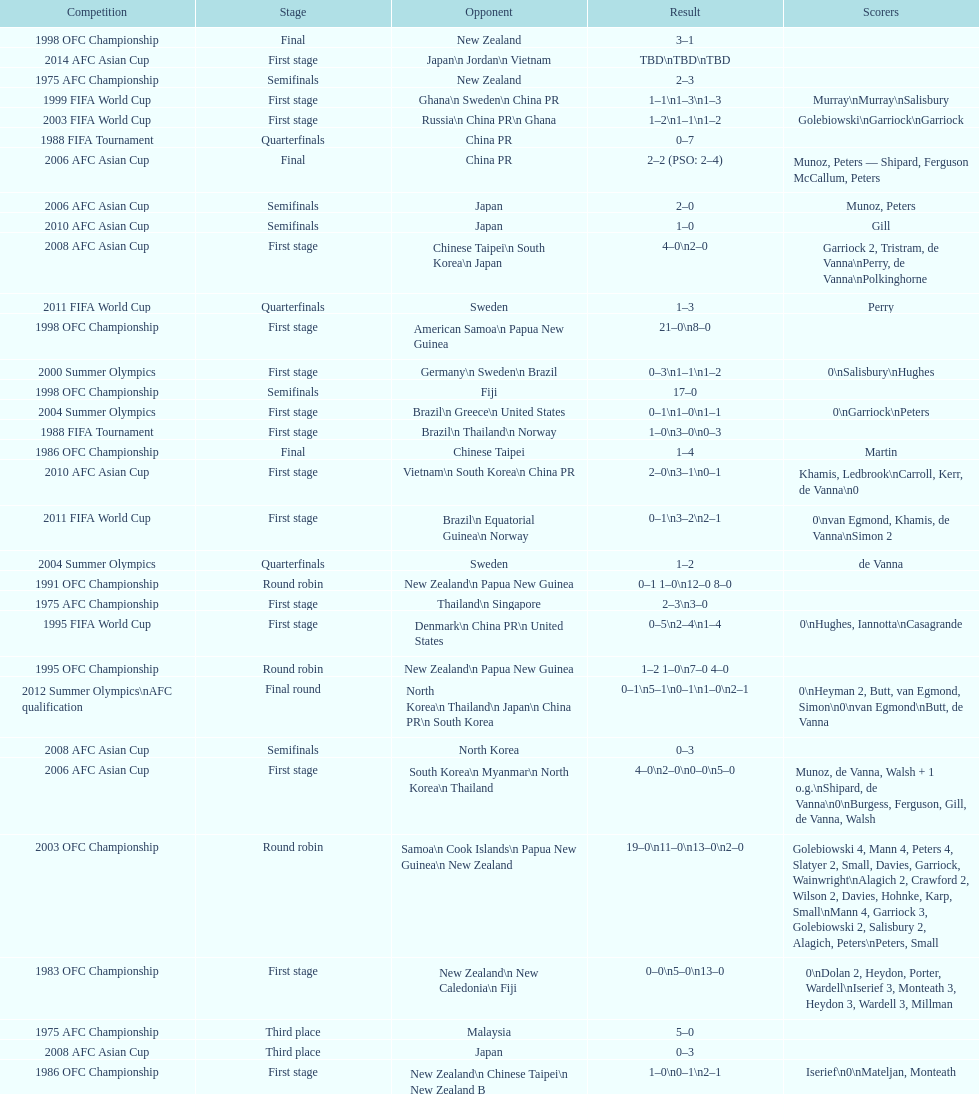Who scored better in the 1995 fifa world cup denmark or the united states? United States. 